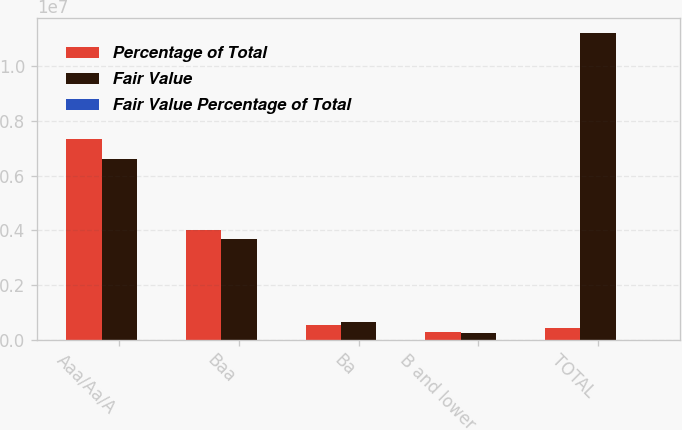Convert chart to OTSL. <chart><loc_0><loc_0><loc_500><loc_500><stacked_bar_chart><ecel><fcel>Aaa/Aa/A<fcel>Baa<fcel>Ba<fcel>B and lower<fcel>TOTAL<nl><fcel>Percentage of Total<fcel>7.31901e+06<fcel>4.01461e+06<fcel>542756<fcel>295270<fcel>419013<nl><fcel>Fair Value<fcel>6.62081e+06<fcel>3.69271e+06<fcel>648817<fcel>230265<fcel>1.11926e+07<nl><fcel>Fair Value Percentage of Total<fcel>59<fcel>33<fcel>6<fcel>2<fcel>100<nl></chart> 